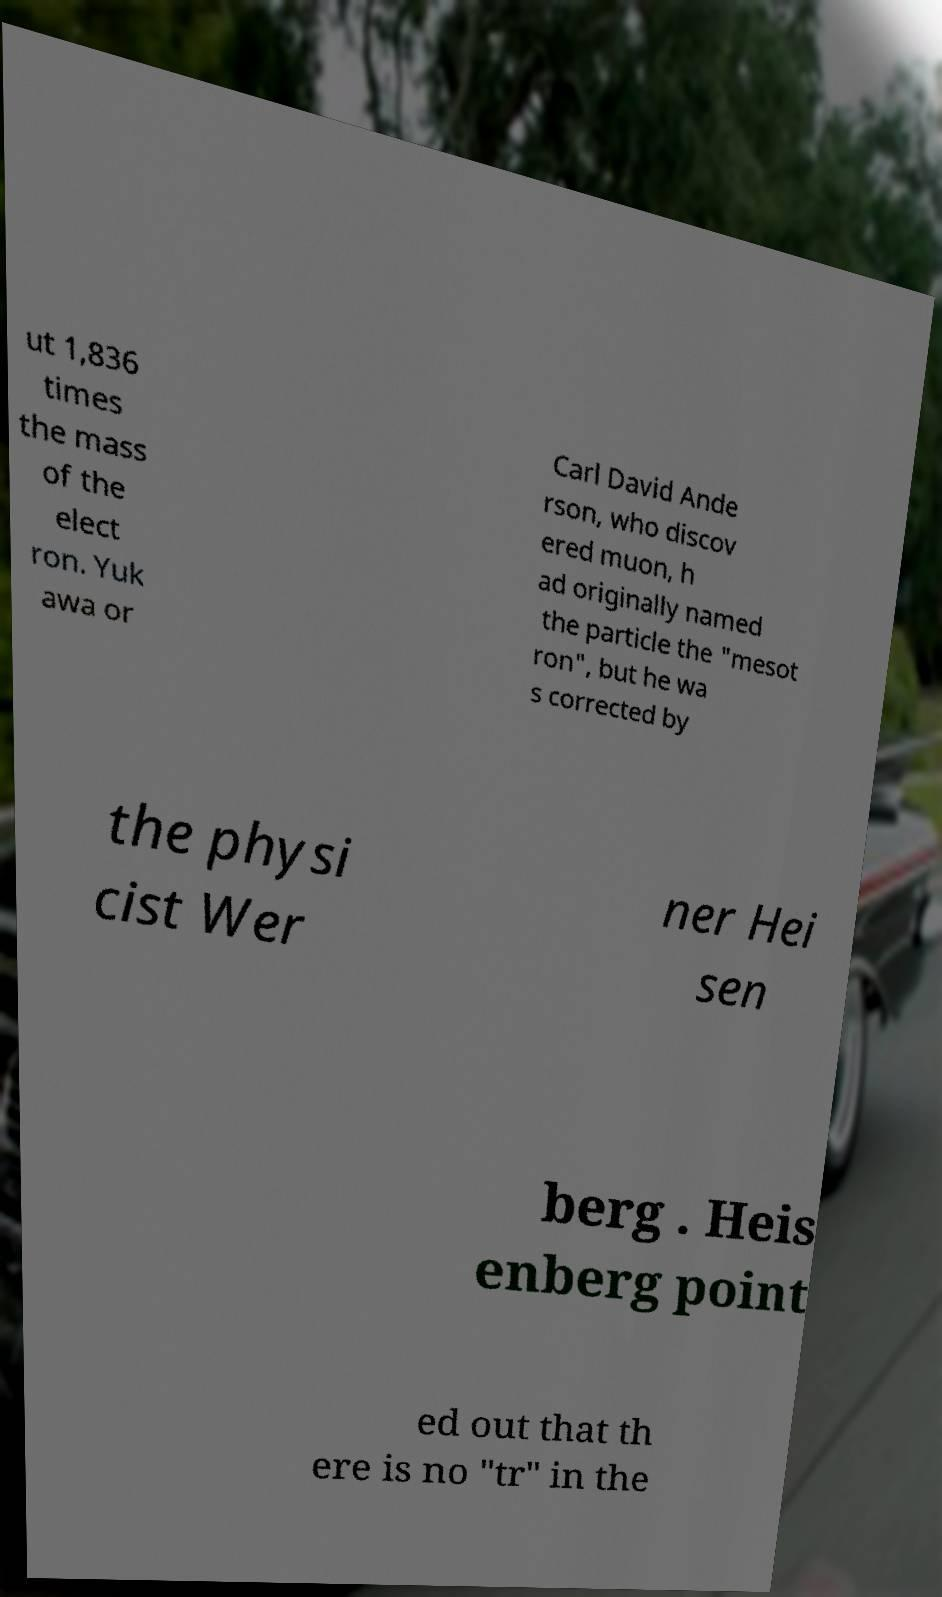Could you extract and type out the text from this image? ut 1,836 times the mass of the elect ron. Yuk awa or Carl David Ande rson, who discov ered muon, h ad originally named the particle the "mesot ron", but he wa s corrected by the physi cist Wer ner Hei sen berg . Heis enberg point ed out that th ere is no "tr" in the 